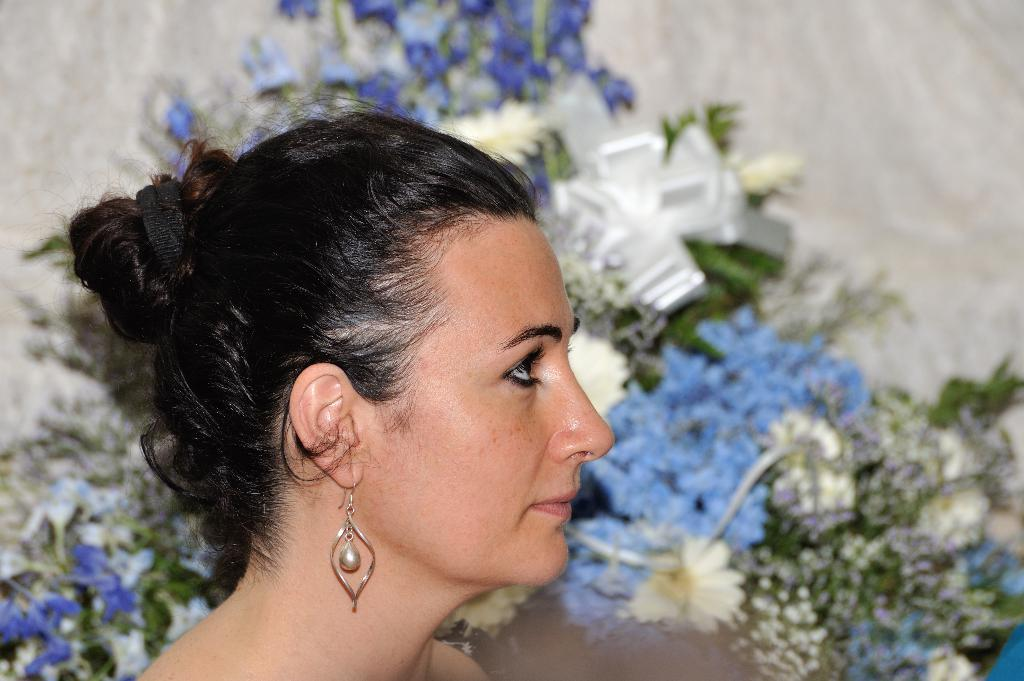What is the main subject of the image? There is a woman's face in the image. What can be seen in the background of the image? There are flowers and leaves in the background of the image. What type of accessory is the woman wearing? The woman is wearing an earring. What material is visible in the image? There is cloth visible in the image. What type of breakfast is the woman eating in the image? There is no breakfast present in the image; it only features a woman's face and the background. What type of beam can be seen supporting the structure in the image? There is no structure or beam present in the image; it only features a woman's face and the background. 